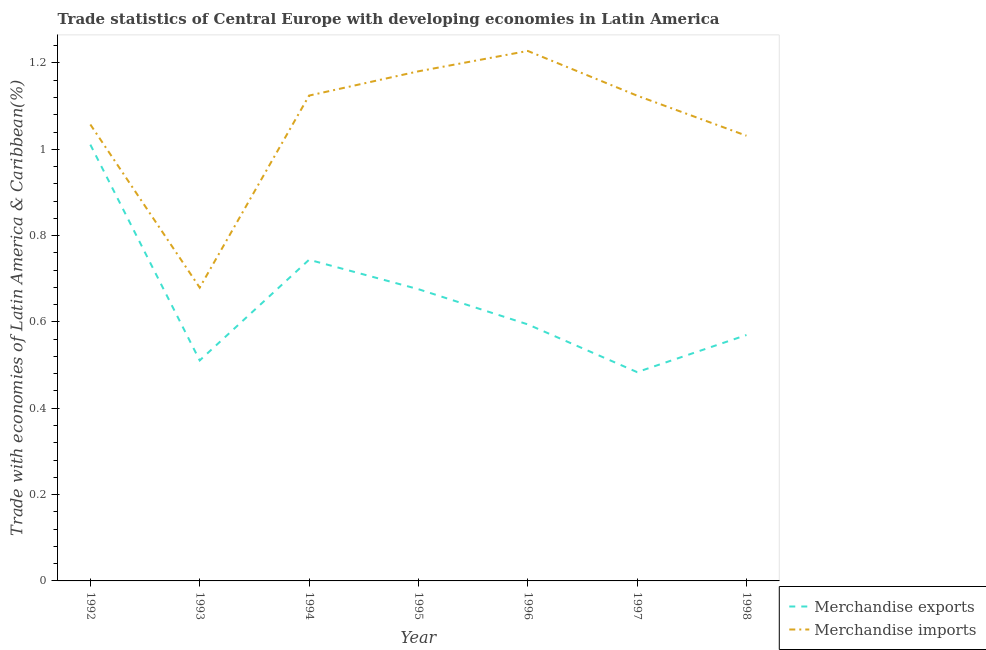Is the number of lines equal to the number of legend labels?
Offer a very short reply. Yes. What is the merchandise imports in 1997?
Offer a very short reply. 1.12. Across all years, what is the maximum merchandise exports?
Provide a short and direct response. 1.01. Across all years, what is the minimum merchandise imports?
Make the answer very short. 0.68. In which year was the merchandise exports maximum?
Ensure brevity in your answer.  1992. What is the total merchandise imports in the graph?
Ensure brevity in your answer.  7.43. What is the difference between the merchandise imports in 1993 and that in 1997?
Your answer should be compact. -0.44. What is the difference between the merchandise exports in 1998 and the merchandise imports in 1995?
Make the answer very short. -0.61. What is the average merchandise exports per year?
Ensure brevity in your answer.  0.66. In the year 1995, what is the difference between the merchandise imports and merchandise exports?
Offer a very short reply. 0.5. In how many years, is the merchandise imports greater than 0.92 %?
Keep it short and to the point. 6. What is the ratio of the merchandise exports in 1995 to that in 1997?
Offer a very short reply. 1.4. What is the difference between the highest and the second highest merchandise imports?
Offer a terse response. 0.05. What is the difference between the highest and the lowest merchandise exports?
Offer a terse response. 0.53. In how many years, is the merchandise imports greater than the average merchandise imports taken over all years?
Make the answer very short. 4. Does the merchandise exports monotonically increase over the years?
Give a very brief answer. No. Is the merchandise exports strictly greater than the merchandise imports over the years?
Your response must be concise. No. How many years are there in the graph?
Ensure brevity in your answer.  7. What is the difference between two consecutive major ticks on the Y-axis?
Give a very brief answer. 0.2. Does the graph contain grids?
Provide a succinct answer. No. How many legend labels are there?
Offer a very short reply. 2. How are the legend labels stacked?
Make the answer very short. Vertical. What is the title of the graph?
Ensure brevity in your answer.  Trade statistics of Central Europe with developing economies in Latin America. What is the label or title of the Y-axis?
Ensure brevity in your answer.  Trade with economies of Latin America & Caribbean(%). What is the Trade with economies of Latin America & Caribbean(%) of Merchandise exports in 1992?
Make the answer very short. 1.01. What is the Trade with economies of Latin America & Caribbean(%) of Merchandise imports in 1992?
Your response must be concise. 1.06. What is the Trade with economies of Latin America & Caribbean(%) of Merchandise exports in 1993?
Provide a short and direct response. 0.51. What is the Trade with economies of Latin America & Caribbean(%) in Merchandise imports in 1993?
Ensure brevity in your answer.  0.68. What is the Trade with economies of Latin America & Caribbean(%) in Merchandise exports in 1994?
Your answer should be very brief. 0.74. What is the Trade with economies of Latin America & Caribbean(%) of Merchandise imports in 1994?
Make the answer very short. 1.12. What is the Trade with economies of Latin America & Caribbean(%) in Merchandise exports in 1995?
Your answer should be compact. 0.68. What is the Trade with economies of Latin America & Caribbean(%) of Merchandise imports in 1995?
Keep it short and to the point. 1.18. What is the Trade with economies of Latin America & Caribbean(%) of Merchandise exports in 1996?
Offer a very short reply. 0.59. What is the Trade with economies of Latin America & Caribbean(%) in Merchandise imports in 1996?
Your response must be concise. 1.23. What is the Trade with economies of Latin America & Caribbean(%) of Merchandise exports in 1997?
Provide a succinct answer. 0.48. What is the Trade with economies of Latin America & Caribbean(%) in Merchandise imports in 1997?
Make the answer very short. 1.12. What is the Trade with economies of Latin America & Caribbean(%) of Merchandise exports in 1998?
Provide a succinct answer. 0.57. What is the Trade with economies of Latin America & Caribbean(%) in Merchandise imports in 1998?
Provide a short and direct response. 1.03. Across all years, what is the maximum Trade with economies of Latin America & Caribbean(%) of Merchandise exports?
Your answer should be compact. 1.01. Across all years, what is the maximum Trade with economies of Latin America & Caribbean(%) in Merchandise imports?
Offer a terse response. 1.23. Across all years, what is the minimum Trade with economies of Latin America & Caribbean(%) of Merchandise exports?
Provide a short and direct response. 0.48. Across all years, what is the minimum Trade with economies of Latin America & Caribbean(%) in Merchandise imports?
Offer a terse response. 0.68. What is the total Trade with economies of Latin America & Caribbean(%) in Merchandise exports in the graph?
Give a very brief answer. 4.59. What is the total Trade with economies of Latin America & Caribbean(%) in Merchandise imports in the graph?
Keep it short and to the point. 7.43. What is the difference between the Trade with economies of Latin America & Caribbean(%) in Merchandise exports in 1992 and that in 1993?
Keep it short and to the point. 0.5. What is the difference between the Trade with economies of Latin America & Caribbean(%) of Merchandise imports in 1992 and that in 1993?
Your response must be concise. 0.38. What is the difference between the Trade with economies of Latin America & Caribbean(%) of Merchandise exports in 1992 and that in 1994?
Provide a succinct answer. 0.27. What is the difference between the Trade with economies of Latin America & Caribbean(%) of Merchandise imports in 1992 and that in 1994?
Make the answer very short. -0.07. What is the difference between the Trade with economies of Latin America & Caribbean(%) in Merchandise exports in 1992 and that in 1995?
Your answer should be compact. 0.33. What is the difference between the Trade with economies of Latin America & Caribbean(%) of Merchandise imports in 1992 and that in 1995?
Your response must be concise. -0.12. What is the difference between the Trade with economies of Latin America & Caribbean(%) in Merchandise exports in 1992 and that in 1996?
Your response must be concise. 0.42. What is the difference between the Trade with economies of Latin America & Caribbean(%) in Merchandise imports in 1992 and that in 1996?
Ensure brevity in your answer.  -0.17. What is the difference between the Trade with economies of Latin America & Caribbean(%) in Merchandise exports in 1992 and that in 1997?
Ensure brevity in your answer.  0.53. What is the difference between the Trade with economies of Latin America & Caribbean(%) in Merchandise imports in 1992 and that in 1997?
Offer a very short reply. -0.07. What is the difference between the Trade with economies of Latin America & Caribbean(%) of Merchandise exports in 1992 and that in 1998?
Keep it short and to the point. 0.44. What is the difference between the Trade with economies of Latin America & Caribbean(%) of Merchandise imports in 1992 and that in 1998?
Keep it short and to the point. 0.03. What is the difference between the Trade with economies of Latin America & Caribbean(%) in Merchandise exports in 1993 and that in 1994?
Ensure brevity in your answer.  -0.23. What is the difference between the Trade with economies of Latin America & Caribbean(%) of Merchandise imports in 1993 and that in 1994?
Give a very brief answer. -0.44. What is the difference between the Trade with economies of Latin America & Caribbean(%) in Merchandise exports in 1993 and that in 1995?
Keep it short and to the point. -0.17. What is the difference between the Trade with economies of Latin America & Caribbean(%) in Merchandise imports in 1993 and that in 1995?
Provide a short and direct response. -0.5. What is the difference between the Trade with economies of Latin America & Caribbean(%) of Merchandise exports in 1993 and that in 1996?
Give a very brief answer. -0.08. What is the difference between the Trade with economies of Latin America & Caribbean(%) in Merchandise imports in 1993 and that in 1996?
Offer a very short reply. -0.55. What is the difference between the Trade with economies of Latin America & Caribbean(%) in Merchandise exports in 1993 and that in 1997?
Offer a very short reply. 0.03. What is the difference between the Trade with economies of Latin America & Caribbean(%) in Merchandise imports in 1993 and that in 1997?
Your response must be concise. -0.44. What is the difference between the Trade with economies of Latin America & Caribbean(%) in Merchandise exports in 1993 and that in 1998?
Offer a terse response. -0.06. What is the difference between the Trade with economies of Latin America & Caribbean(%) of Merchandise imports in 1993 and that in 1998?
Your answer should be very brief. -0.35. What is the difference between the Trade with economies of Latin America & Caribbean(%) in Merchandise exports in 1994 and that in 1995?
Provide a short and direct response. 0.07. What is the difference between the Trade with economies of Latin America & Caribbean(%) in Merchandise imports in 1994 and that in 1995?
Provide a succinct answer. -0.06. What is the difference between the Trade with economies of Latin America & Caribbean(%) in Merchandise exports in 1994 and that in 1996?
Provide a succinct answer. 0.15. What is the difference between the Trade with economies of Latin America & Caribbean(%) in Merchandise imports in 1994 and that in 1996?
Ensure brevity in your answer.  -0.1. What is the difference between the Trade with economies of Latin America & Caribbean(%) in Merchandise exports in 1994 and that in 1997?
Your answer should be compact. 0.26. What is the difference between the Trade with economies of Latin America & Caribbean(%) of Merchandise imports in 1994 and that in 1997?
Keep it short and to the point. 0. What is the difference between the Trade with economies of Latin America & Caribbean(%) in Merchandise exports in 1994 and that in 1998?
Offer a very short reply. 0.17. What is the difference between the Trade with economies of Latin America & Caribbean(%) of Merchandise imports in 1994 and that in 1998?
Provide a short and direct response. 0.09. What is the difference between the Trade with economies of Latin America & Caribbean(%) in Merchandise exports in 1995 and that in 1996?
Your answer should be compact. 0.08. What is the difference between the Trade with economies of Latin America & Caribbean(%) of Merchandise imports in 1995 and that in 1996?
Ensure brevity in your answer.  -0.05. What is the difference between the Trade with economies of Latin America & Caribbean(%) of Merchandise exports in 1995 and that in 1997?
Keep it short and to the point. 0.19. What is the difference between the Trade with economies of Latin America & Caribbean(%) in Merchandise imports in 1995 and that in 1997?
Offer a terse response. 0.06. What is the difference between the Trade with economies of Latin America & Caribbean(%) of Merchandise exports in 1995 and that in 1998?
Provide a short and direct response. 0.11. What is the difference between the Trade with economies of Latin America & Caribbean(%) of Merchandise imports in 1995 and that in 1998?
Offer a terse response. 0.15. What is the difference between the Trade with economies of Latin America & Caribbean(%) in Merchandise exports in 1996 and that in 1997?
Provide a short and direct response. 0.11. What is the difference between the Trade with economies of Latin America & Caribbean(%) in Merchandise imports in 1996 and that in 1997?
Offer a very short reply. 0.1. What is the difference between the Trade with economies of Latin America & Caribbean(%) in Merchandise exports in 1996 and that in 1998?
Offer a terse response. 0.02. What is the difference between the Trade with economies of Latin America & Caribbean(%) in Merchandise imports in 1996 and that in 1998?
Ensure brevity in your answer.  0.2. What is the difference between the Trade with economies of Latin America & Caribbean(%) of Merchandise exports in 1997 and that in 1998?
Keep it short and to the point. -0.09. What is the difference between the Trade with economies of Latin America & Caribbean(%) in Merchandise imports in 1997 and that in 1998?
Your answer should be very brief. 0.09. What is the difference between the Trade with economies of Latin America & Caribbean(%) of Merchandise exports in 1992 and the Trade with economies of Latin America & Caribbean(%) of Merchandise imports in 1993?
Keep it short and to the point. 0.33. What is the difference between the Trade with economies of Latin America & Caribbean(%) of Merchandise exports in 1992 and the Trade with economies of Latin America & Caribbean(%) of Merchandise imports in 1994?
Give a very brief answer. -0.11. What is the difference between the Trade with economies of Latin America & Caribbean(%) of Merchandise exports in 1992 and the Trade with economies of Latin America & Caribbean(%) of Merchandise imports in 1995?
Make the answer very short. -0.17. What is the difference between the Trade with economies of Latin America & Caribbean(%) in Merchandise exports in 1992 and the Trade with economies of Latin America & Caribbean(%) in Merchandise imports in 1996?
Your answer should be compact. -0.22. What is the difference between the Trade with economies of Latin America & Caribbean(%) in Merchandise exports in 1992 and the Trade with economies of Latin America & Caribbean(%) in Merchandise imports in 1997?
Your answer should be compact. -0.11. What is the difference between the Trade with economies of Latin America & Caribbean(%) of Merchandise exports in 1992 and the Trade with economies of Latin America & Caribbean(%) of Merchandise imports in 1998?
Make the answer very short. -0.02. What is the difference between the Trade with economies of Latin America & Caribbean(%) in Merchandise exports in 1993 and the Trade with economies of Latin America & Caribbean(%) in Merchandise imports in 1994?
Your answer should be very brief. -0.61. What is the difference between the Trade with economies of Latin America & Caribbean(%) in Merchandise exports in 1993 and the Trade with economies of Latin America & Caribbean(%) in Merchandise imports in 1995?
Make the answer very short. -0.67. What is the difference between the Trade with economies of Latin America & Caribbean(%) in Merchandise exports in 1993 and the Trade with economies of Latin America & Caribbean(%) in Merchandise imports in 1996?
Ensure brevity in your answer.  -0.72. What is the difference between the Trade with economies of Latin America & Caribbean(%) of Merchandise exports in 1993 and the Trade with economies of Latin America & Caribbean(%) of Merchandise imports in 1997?
Ensure brevity in your answer.  -0.61. What is the difference between the Trade with economies of Latin America & Caribbean(%) of Merchandise exports in 1993 and the Trade with economies of Latin America & Caribbean(%) of Merchandise imports in 1998?
Offer a very short reply. -0.52. What is the difference between the Trade with economies of Latin America & Caribbean(%) of Merchandise exports in 1994 and the Trade with economies of Latin America & Caribbean(%) of Merchandise imports in 1995?
Offer a very short reply. -0.44. What is the difference between the Trade with economies of Latin America & Caribbean(%) in Merchandise exports in 1994 and the Trade with economies of Latin America & Caribbean(%) in Merchandise imports in 1996?
Make the answer very short. -0.48. What is the difference between the Trade with economies of Latin America & Caribbean(%) of Merchandise exports in 1994 and the Trade with economies of Latin America & Caribbean(%) of Merchandise imports in 1997?
Ensure brevity in your answer.  -0.38. What is the difference between the Trade with economies of Latin America & Caribbean(%) in Merchandise exports in 1994 and the Trade with economies of Latin America & Caribbean(%) in Merchandise imports in 1998?
Provide a short and direct response. -0.29. What is the difference between the Trade with economies of Latin America & Caribbean(%) in Merchandise exports in 1995 and the Trade with economies of Latin America & Caribbean(%) in Merchandise imports in 1996?
Give a very brief answer. -0.55. What is the difference between the Trade with economies of Latin America & Caribbean(%) of Merchandise exports in 1995 and the Trade with economies of Latin America & Caribbean(%) of Merchandise imports in 1997?
Provide a succinct answer. -0.45. What is the difference between the Trade with economies of Latin America & Caribbean(%) in Merchandise exports in 1995 and the Trade with economies of Latin America & Caribbean(%) in Merchandise imports in 1998?
Give a very brief answer. -0.36. What is the difference between the Trade with economies of Latin America & Caribbean(%) in Merchandise exports in 1996 and the Trade with economies of Latin America & Caribbean(%) in Merchandise imports in 1997?
Your answer should be compact. -0.53. What is the difference between the Trade with economies of Latin America & Caribbean(%) in Merchandise exports in 1996 and the Trade with economies of Latin America & Caribbean(%) in Merchandise imports in 1998?
Your answer should be compact. -0.44. What is the difference between the Trade with economies of Latin America & Caribbean(%) in Merchandise exports in 1997 and the Trade with economies of Latin America & Caribbean(%) in Merchandise imports in 1998?
Give a very brief answer. -0.55. What is the average Trade with economies of Latin America & Caribbean(%) of Merchandise exports per year?
Give a very brief answer. 0.66. What is the average Trade with economies of Latin America & Caribbean(%) of Merchandise imports per year?
Provide a succinct answer. 1.06. In the year 1992, what is the difference between the Trade with economies of Latin America & Caribbean(%) of Merchandise exports and Trade with economies of Latin America & Caribbean(%) of Merchandise imports?
Your answer should be compact. -0.05. In the year 1993, what is the difference between the Trade with economies of Latin America & Caribbean(%) of Merchandise exports and Trade with economies of Latin America & Caribbean(%) of Merchandise imports?
Offer a terse response. -0.17. In the year 1994, what is the difference between the Trade with economies of Latin America & Caribbean(%) of Merchandise exports and Trade with economies of Latin America & Caribbean(%) of Merchandise imports?
Offer a terse response. -0.38. In the year 1995, what is the difference between the Trade with economies of Latin America & Caribbean(%) of Merchandise exports and Trade with economies of Latin America & Caribbean(%) of Merchandise imports?
Provide a succinct answer. -0.5. In the year 1996, what is the difference between the Trade with economies of Latin America & Caribbean(%) of Merchandise exports and Trade with economies of Latin America & Caribbean(%) of Merchandise imports?
Give a very brief answer. -0.63. In the year 1997, what is the difference between the Trade with economies of Latin America & Caribbean(%) of Merchandise exports and Trade with economies of Latin America & Caribbean(%) of Merchandise imports?
Keep it short and to the point. -0.64. In the year 1998, what is the difference between the Trade with economies of Latin America & Caribbean(%) in Merchandise exports and Trade with economies of Latin America & Caribbean(%) in Merchandise imports?
Ensure brevity in your answer.  -0.46. What is the ratio of the Trade with economies of Latin America & Caribbean(%) in Merchandise exports in 1992 to that in 1993?
Provide a succinct answer. 1.98. What is the ratio of the Trade with economies of Latin America & Caribbean(%) in Merchandise imports in 1992 to that in 1993?
Provide a succinct answer. 1.56. What is the ratio of the Trade with economies of Latin America & Caribbean(%) of Merchandise exports in 1992 to that in 1994?
Provide a short and direct response. 1.36. What is the ratio of the Trade with economies of Latin America & Caribbean(%) in Merchandise imports in 1992 to that in 1994?
Offer a terse response. 0.94. What is the ratio of the Trade with economies of Latin America & Caribbean(%) of Merchandise exports in 1992 to that in 1995?
Provide a succinct answer. 1.5. What is the ratio of the Trade with economies of Latin America & Caribbean(%) in Merchandise imports in 1992 to that in 1995?
Offer a very short reply. 0.9. What is the ratio of the Trade with economies of Latin America & Caribbean(%) of Merchandise exports in 1992 to that in 1996?
Provide a succinct answer. 1.7. What is the ratio of the Trade with economies of Latin America & Caribbean(%) of Merchandise imports in 1992 to that in 1996?
Provide a short and direct response. 0.86. What is the ratio of the Trade with economies of Latin America & Caribbean(%) in Merchandise exports in 1992 to that in 1997?
Provide a succinct answer. 2.09. What is the ratio of the Trade with economies of Latin America & Caribbean(%) in Merchandise imports in 1992 to that in 1997?
Your answer should be compact. 0.94. What is the ratio of the Trade with economies of Latin America & Caribbean(%) of Merchandise exports in 1992 to that in 1998?
Make the answer very short. 1.77. What is the ratio of the Trade with economies of Latin America & Caribbean(%) in Merchandise imports in 1992 to that in 1998?
Offer a very short reply. 1.03. What is the ratio of the Trade with economies of Latin America & Caribbean(%) in Merchandise exports in 1993 to that in 1994?
Make the answer very short. 0.69. What is the ratio of the Trade with economies of Latin America & Caribbean(%) in Merchandise imports in 1993 to that in 1994?
Your response must be concise. 0.6. What is the ratio of the Trade with economies of Latin America & Caribbean(%) of Merchandise exports in 1993 to that in 1995?
Ensure brevity in your answer.  0.76. What is the ratio of the Trade with economies of Latin America & Caribbean(%) in Merchandise imports in 1993 to that in 1995?
Your answer should be compact. 0.58. What is the ratio of the Trade with economies of Latin America & Caribbean(%) of Merchandise exports in 1993 to that in 1996?
Give a very brief answer. 0.86. What is the ratio of the Trade with economies of Latin America & Caribbean(%) in Merchandise imports in 1993 to that in 1996?
Your answer should be compact. 0.55. What is the ratio of the Trade with economies of Latin America & Caribbean(%) of Merchandise exports in 1993 to that in 1997?
Your response must be concise. 1.06. What is the ratio of the Trade with economies of Latin America & Caribbean(%) of Merchandise imports in 1993 to that in 1997?
Keep it short and to the point. 0.6. What is the ratio of the Trade with economies of Latin America & Caribbean(%) in Merchandise exports in 1993 to that in 1998?
Make the answer very short. 0.9. What is the ratio of the Trade with economies of Latin America & Caribbean(%) of Merchandise imports in 1993 to that in 1998?
Ensure brevity in your answer.  0.66. What is the ratio of the Trade with economies of Latin America & Caribbean(%) of Merchandise exports in 1994 to that in 1995?
Make the answer very short. 1.1. What is the ratio of the Trade with economies of Latin America & Caribbean(%) in Merchandise imports in 1994 to that in 1995?
Provide a succinct answer. 0.95. What is the ratio of the Trade with economies of Latin America & Caribbean(%) in Merchandise exports in 1994 to that in 1996?
Provide a short and direct response. 1.25. What is the ratio of the Trade with economies of Latin America & Caribbean(%) in Merchandise imports in 1994 to that in 1996?
Make the answer very short. 0.92. What is the ratio of the Trade with economies of Latin America & Caribbean(%) in Merchandise exports in 1994 to that in 1997?
Keep it short and to the point. 1.54. What is the ratio of the Trade with economies of Latin America & Caribbean(%) of Merchandise imports in 1994 to that in 1997?
Your answer should be very brief. 1. What is the ratio of the Trade with economies of Latin America & Caribbean(%) in Merchandise exports in 1994 to that in 1998?
Offer a very short reply. 1.31. What is the ratio of the Trade with economies of Latin America & Caribbean(%) of Merchandise imports in 1994 to that in 1998?
Keep it short and to the point. 1.09. What is the ratio of the Trade with economies of Latin America & Caribbean(%) in Merchandise exports in 1995 to that in 1996?
Ensure brevity in your answer.  1.14. What is the ratio of the Trade with economies of Latin America & Caribbean(%) of Merchandise imports in 1995 to that in 1996?
Give a very brief answer. 0.96. What is the ratio of the Trade with economies of Latin America & Caribbean(%) of Merchandise exports in 1995 to that in 1997?
Give a very brief answer. 1.4. What is the ratio of the Trade with economies of Latin America & Caribbean(%) of Merchandise imports in 1995 to that in 1997?
Ensure brevity in your answer.  1.05. What is the ratio of the Trade with economies of Latin America & Caribbean(%) in Merchandise exports in 1995 to that in 1998?
Your answer should be very brief. 1.19. What is the ratio of the Trade with economies of Latin America & Caribbean(%) in Merchandise imports in 1995 to that in 1998?
Offer a terse response. 1.14. What is the ratio of the Trade with economies of Latin America & Caribbean(%) in Merchandise exports in 1996 to that in 1997?
Make the answer very short. 1.23. What is the ratio of the Trade with economies of Latin America & Caribbean(%) of Merchandise imports in 1996 to that in 1997?
Give a very brief answer. 1.09. What is the ratio of the Trade with economies of Latin America & Caribbean(%) of Merchandise exports in 1996 to that in 1998?
Give a very brief answer. 1.04. What is the ratio of the Trade with economies of Latin America & Caribbean(%) of Merchandise imports in 1996 to that in 1998?
Provide a short and direct response. 1.19. What is the ratio of the Trade with economies of Latin America & Caribbean(%) of Merchandise exports in 1997 to that in 1998?
Give a very brief answer. 0.85. What is the ratio of the Trade with economies of Latin America & Caribbean(%) in Merchandise imports in 1997 to that in 1998?
Your answer should be very brief. 1.09. What is the difference between the highest and the second highest Trade with economies of Latin America & Caribbean(%) of Merchandise exports?
Keep it short and to the point. 0.27. What is the difference between the highest and the second highest Trade with economies of Latin America & Caribbean(%) of Merchandise imports?
Provide a short and direct response. 0.05. What is the difference between the highest and the lowest Trade with economies of Latin America & Caribbean(%) of Merchandise exports?
Provide a succinct answer. 0.53. What is the difference between the highest and the lowest Trade with economies of Latin America & Caribbean(%) in Merchandise imports?
Your response must be concise. 0.55. 